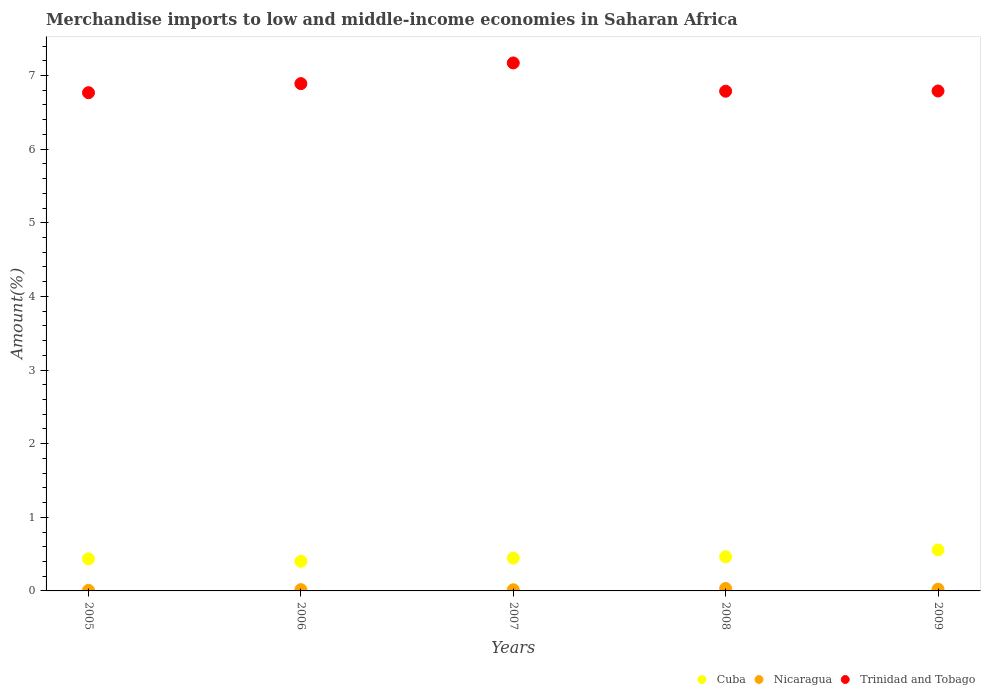How many different coloured dotlines are there?
Offer a terse response. 3. What is the percentage of amount earned from merchandise imports in Trinidad and Tobago in 2009?
Give a very brief answer. 6.79. Across all years, what is the maximum percentage of amount earned from merchandise imports in Trinidad and Tobago?
Give a very brief answer. 7.17. Across all years, what is the minimum percentage of amount earned from merchandise imports in Cuba?
Keep it short and to the point. 0.4. What is the total percentage of amount earned from merchandise imports in Nicaragua in the graph?
Your answer should be very brief. 0.1. What is the difference between the percentage of amount earned from merchandise imports in Cuba in 2006 and that in 2009?
Your answer should be compact. -0.15. What is the difference between the percentage of amount earned from merchandise imports in Cuba in 2006 and the percentage of amount earned from merchandise imports in Trinidad and Tobago in 2008?
Provide a succinct answer. -6.38. What is the average percentage of amount earned from merchandise imports in Cuba per year?
Your response must be concise. 0.46. In the year 2009, what is the difference between the percentage of amount earned from merchandise imports in Cuba and percentage of amount earned from merchandise imports in Trinidad and Tobago?
Keep it short and to the point. -6.23. In how many years, is the percentage of amount earned from merchandise imports in Cuba greater than 0.2 %?
Keep it short and to the point. 5. What is the ratio of the percentage of amount earned from merchandise imports in Nicaragua in 2006 to that in 2009?
Provide a succinct answer. 0.74. Is the percentage of amount earned from merchandise imports in Nicaragua in 2006 less than that in 2009?
Your answer should be very brief. Yes. What is the difference between the highest and the second highest percentage of amount earned from merchandise imports in Cuba?
Your response must be concise. 0.09. What is the difference between the highest and the lowest percentage of amount earned from merchandise imports in Cuba?
Make the answer very short. 0.15. In how many years, is the percentage of amount earned from merchandise imports in Trinidad and Tobago greater than the average percentage of amount earned from merchandise imports in Trinidad and Tobago taken over all years?
Your response must be concise. 2. Is the sum of the percentage of amount earned from merchandise imports in Nicaragua in 2006 and 2007 greater than the maximum percentage of amount earned from merchandise imports in Trinidad and Tobago across all years?
Keep it short and to the point. No. Does the percentage of amount earned from merchandise imports in Cuba monotonically increase over the years?
Offer a terse response. No. Is the percentage of amount earned from merchandise imports in Trinidad and Tobago strictly greater than the percentage of amount earned from merchandise imports in Cuba over the years?
Offer a terse response. Yes. How many dotlines are there?
Your response must be concise. 3. How many years are there in the graph?
Your answer should be compact. 5. What is the difference between two consecutive major ticks on the Y-axis?
Give a very brief answer. 1. Are the values on the major ticks of Y-axis written in scientific E-notation?
Provide a short and direct response. No. Does the graph contain any zero values?
Your response must be concise. No. How many legend labels are there?
Offer a terse response. 3. How are the legend labels stacked?
Your response must be concise. Horizontal. What is the title of the graph?
Your answer should be compact. Merchandise imports to low and middle-income economies in Saharan Africa. Does "Czech Republic" appear as one of the legend labels in the graph?
Your answer should be compact. No. What is the label or title of the Y-axis?
Provide a succinct answer. Amount(%). What is the Amount(%) of Cuba in 2005?
Your answer should be very brief. 0.44. What is the Amount(%) in Nicaragua in 2005?
Your response must be concise. 0.01. What is the Amount(%) of Trinidad and Tobago in 2005?
Your answer should be compact. 6.77. What is the Amount(%) in Cuba in 2006?
Keep it short and to the point. 0.4. What is the Amount(%) in Nicaragua in 2006?
Give a very brief answer. 0.02. What is the Amount(%) of Trinidad and Tobago in 2006?
Keep it short and to the point. 6.89. What is the Amount(%) in Cuba in 2007?
Make the answer very short. 0.45. What is the Amount(%) in Nicaragua in 2007?
Provide a succinct answer. 0.02. What is the Amount(%) in Trinidad and Tobago in 2007?
Provide a succinct answer. 7.17. What is the Amount(%) in Cuba in 2008?
Give a very brief answer. 0.46. What is the Amount(%) in Nicaragua in 2008?
Keep it short and to the point. 0.03. What is the Amount(%) in Trinidad and Tobago in 2008?
Your answer should be very brief. 6.79. What is the Amount(%) of Cuba in 2009?
Offer a terse response. 0.56. What is the Amount(%) of Nicaragua in 2009?
Offer a very short reply. 0.02. What is the Amount(%) in Trinidad and Tobago in 2009?
Provide a short and direct response. 6.79. Across all years, what is the maximum Amount(%) in Cuba?
Make the answer very short. 0.56. Across all years, what is the maximum Amount(%) of Nicaragua?
Your answer should be compact. 0.03. Across all years, what is the maximum Amount(%) of Trinidad and Tobago?
Keep it short and to the point. 7.17. Across all years, what is the minimum Amount(%) of Cuba?
Provide a succinct answer. 0.4. Across all years, what is the minimum Amount(%) of Nicaragua?
Offer a terse response. 0.01. Across all years, what is the minimum Amount(%) of Trinidad and Tobago?
Give a very brief answer. 6.77. What is the total Amount(%) of Cuba in the graph?
Keep it short and to the point. 2.3. What is the total Amount(%) of Nicaragua in the graph?
Give a very brief answer. 0.1. What is the total Amount(%) of Trinidad and Tobago in the graph?
Provide a succinct answer. 34.4. What is the difference between the Amount(%) in Cuba in 2005 and that in 2006?
Your response must be concise. 0.03. What is the difference between the Amount(%) of Nicaragua in 2005 and that in 2006?
Provide a succinct answer. -0.01. What is the difference between the Amount(%) of Trinidad and Tobago in 2005 and that in 2006?
Your answer should be compact. -0.12. What is the difference between the Amount(%) in Cuba in 2005 and that in 2007?
Ensure brevity in your answer.  -0.01. What is the difference between the Amount(%) of Nicaragua in 2005 and that in 2007?
Make the answer very short. -0.01. What is the difference between the Amount(%) of Trinidad and Tobago in 2005 and that in 2007?
Ensure brevity in your answer.  -0.4. What is the difference between the Amount(%) in Cuba in 2005 and that in 2008?
Offer a very short reply. -0.03. What is the difference between the Amount(%) in Nicaragua in 2005 and that in 2008?
Your response must be concise. -0.03. What is the difference between the Amount(%) in Trinidad and Tobago in 2005 and that in 2008?
Make the answer very short. -0.02. What is the difference between the Amount(%) of Cuba in 2005 and that in 2009?
Make the answer very short. -0.12. What is the difference between the Amount(%) in Nicaragua in 2005 and that in 2009?
Make the answer very short. -0.02. What is the difference between the Amount(%) in Trinidad and Tobago in 2005 and that in 2009?
Your answer should be compact. -0.02. What is the difference between the Amount(%) in Cuba in 2006 and that in 2007?
Make the answer very short. -0.04. What is the difference between the Amount(%) of Nicaragua in 2006 and that in 2007?
Provide a short and direct response. 0. What is the difference between the Amount(%) in Trinidad and Tobago in 2006 and that in 2007?
Make the answer very short. -0.28. What is the difference between the Amount(%) of Cuba in 2006 and that in 2008?
Offer a very short reply. -0.06. What is the difference between the Amount(%) in Nicaragua in 2006 and that in 2008?
Keep it short and to the point. -0.02. What is the difference between the Amount(%) of Trinidad and Tobago in 2006 and that in 2008?
Keep it short and to the point. 0.1. What is the difference between the Amount(%) of Cuba in 2006 and that in 2009?
Your answer should be compact. -0.15. What is the difference between the Amount(%) in Nicaragua in 2006 and that in 2009?
Your response must be concise. -0.01. What is the difference between the Amount(%) in Trinidad and Tobago in 2006 and that in 2009?
Your response must be concise. 0.1. What is the difference between the Amount(%) in Cuba in 2007 and that in 2008?
Provide a succinct answer. -0.02. What is the difference between the Amount(%) in Nicaragua in 2007 and that in 2008?
Your answer should be compact. -0.02. What is the difference between the Amount(%) of Trinidad and Tobago in 2007 and that in 2008?
Your response must be concise. 0.38. What is the difference between the Amount(%) of Cuba in 2007 and that in 2009?
Offer a very short reply. -0.11. What is the difference between the Amount(%) of Nicaragua in 2007 and that in 2009?
Your answer should be compact. -0.01. What is the difference between the Amount(%) of Trinidad and Tobago in 2007 and that in 2009?
Keep it short and to the point. 0.38. What is the difference between the Amount(%) of Cuba in 2008 and that in 2009?
Offer a very short reply. -0.09. What is the difference between the Amount(%) in Nicaragua in 2008 and that in 2009?
Give a very brief answer. 0.01. What is the difference between the Amount(%) of Trinidad and Tobago in 2008 and that in 2009?
Provide a short and direct response. -0. What is the difference between the Amount(%) of Cuba in 2005 and the Amount(%) of Nicaragua in 2006?
Your response must be concise. 0.42. What is the difference between the Amount(%) of Cuba in 2005 and the Amount(%) of Trinidad and Tobago in 2006?
Offer a terse response. -6.45. What is the difference between the Amount(%) in Nicaragua in 2005 and the Amount(%) in Trinidad and Tobago in 2006?
Provide a short and direct response. -6.88. What is the difference between the Amount(%) in Cuba in 2005 and the Amount(%) in Nicaragua in 2007?
Offer a terse response. 0.42. What is the difference between the Amount(%) in Cuba in 2005 and the Amount(%) in Trinidad and Tobago in 2007?
Ensure brevity in your answer.  -6.74. What is the difference between the Amount(%) in Nicaragua in 2005 and the Amount(%) in Trinidad and Tobago in 2007?
Give a very brief answer. -7.16. What is the difference between the Amount(%) in Cuba in 2005 and the Amount(%) in Nicaragua in 2008?
Ensure brevity in your answer.  0.4. What is the difference between the Amount(%) of Cuba in 2005 and the Amount(%) of Trinidad and Tobago in 2008?
Your answer should be compact. -6.35. What is the difference between the Amount(%) of Nicaragua in 2005 and the Amount(%) of Trinidad and Tobago in 2008?
Give a very brief answer. -6.78. What is the difference between the Amount(%) of Cuba in 2005 and the Amount(%) of Nicaragua in 2009?
Your answer should be very brief. 0.41. What is the difference between the Amount(%) of Cuba in 2005 and the Amount(%) of Trinidad and Tobago in 2009?
Your answer should be compact. -6.35. What is the difference between the Amount(%) in Nicaragua in 2005 and the Amount(%) in Trinidad and Tobago in 2009?
Ensure brevity in your answer.  -6.78. What is the difference between the Amount(%) in Cuba in 2006 and the Amount(%) in Nicaragua in 2007?
Provide a short and direct response. 0.39. What is the difference between the Amount(%) of Cuba in 2006 and the Amount(%) of Trinidad and Tobago in 2007?
Give a very brief answer. -6.77. What is the difference between the Amount(%) of Nicaragua in 2006 and the Amount(%) of Trinidad and Tobago in 2007?
Ensure brevity in your answer.  -7.15. What is the difference between the Amount(%) in Cuba in 2006 and the Amount(%) in Nicaragua in 2008?
Make the answer very short. 0.37. What is the difference between the Amount(%) of Cuba in 2006 and the Amount(%) of Trinidad and Tobago in 2008?
Offer a terse response. -6.38. What is the difference between the Amount(%) of Nicaragua in 2006 and the Amount(%) of Trinidad and Tobago in 2008?
Provide a succinct answer. -6.77. What is the difference between the Amount(%) of Cuba in 2006 and the Amount(%) of Nicaragua in 2009?
Make the answer very short. 0.38. What is the difference between the Amount(%) of Cuba in 2006 and the Amount(%) of Trinidad and Tobago in 2009?
Give a very brief answer. -6.39. What is the difference between the Amount(%) in Nicaragua in 2006 and the Amount(%) in Trinidad and Tobago in 2009?
Offer a very short reply. -6.77. What is the difference between the Amount(%) in Cuba in 2007 and the Amount(%) in Nicaragua in 2008?
Your answer should be very brief. 0.41. What is the difference between the Amount(%) in Cuba in 2007 and the Amount(%) in Trinidad and Tobago in 2008?
Your answer should be compact. -6.34. What is the difference between the Amount(%) of Nicaragua in 2007 and the Amount(%) of Trinidad and Tobago in 2008?
Offer a terse response. -6.77. What is the difference between the Amount(%) in Cuba in 2007 and the Amount(%) in Nicaragua in 2009?
Offer a very short reply. 0.42. What is the difference between the Amount(%) in Cuba in 2007 and the Amount(%) in Trinidad and Tobago in 2009?
Offer a terse response. -6.34. What is the difference between the Amount(%) in Nicaragua in 2007 and the Amount(%) in Trinidad and Tobago in 2009?
Your answer should be compact. -6.77. What is the difference between the Amount(%) in Cuba in 2008 and the Amount(%) in Nicaragua in 2009?
Your answer should be very brief. 0.44. What is the difference between the Amount(%) of Cuba in 2008 and the Amount(%) of Trinidad and Tobago in 2009?
Your answer should be compact. -6.33. What is the difference between the Amount(%) of Nicaragua in 2008 and the Amount(%) of Trinidad and Tobago in 2009?
Offer a very short reply. -6.76. What is the average Amount(%) in Cuba per year?
Your response must be concise. 0.46. What is the average Amount(%) in Nicaragua per year?
Ensure brevity in your answer.  0.02. What is the average Amount(%) of Trinidad and Tobago per year?
Your answer should be compact. 6.88. In the year 2005, what is the difference between the Amount(%) in Cuba and Amount(%) in Nicaragua?
Your response must be concise. 0.43. In the year 2005, what is the difference between the Amount(%) in Cuba and Amount(%) in Trinidad and Tobago?
Ensure brevity in your answer.  -6.33. In the year 2005, what is the difference between the Amount(%) of Nicaragua and Amount(%) of Trinidad and Tobago?
Ensure brevity in your answer.  -6.76. In the year 2006, what is the difference between the Amount(%) of Cuba and Amount(%) of Nicaragua?
Give a very brief answer. 0.39. In the year 2006, what is the difference between the Amount(%) in Cuba and Amount(%) in Trinidad and Tobago?
Provide a succinct answer. -6.49. In the year 2006, what is the difference between the Amount(%) of Nicaragua and Amount(%) of Trinidad and Tobago?
Ensure brevity in your answer.  -6.87. In the year 2007, what is the difference between the Amount(%) of Cuba and Amount(%) of Nicaragua?
Your response must be concise. 0.43. In the year 2007, what is the difference between the Amount(%) in Cuba and Amount(%) in Trinidad and Tobago?
Make the answer very short. -6.72. In the year 2007, what is the difference between the Amount(%) of Nicaragua and Amount(%) of Trinidad and Tobago?
Ensure brevity in your answer.  -7.16. In the year 2008, what is the difference between the Amount(%) in Cuba and Amount(%) in Nicaragua?
Make the answer very short. 0.43. In the year 2008, what is the difference between the Amount(%) of Cuba and Amount(%) of Trinidad and Tobago?
Provide a short and direct response. -6.32. In the year 2008, what is the difference between the Amount(%) of Nicaragua and Amount(%) of Trinidad and Tobago?
Keep it short and to the point. -6.75. In the year 2009, what is the difference between the Amount(%) in Cuba and Amount(%) in Nicaragua?
Your answer should be very brief. 0.53. In the year 2009, what is the difference between the Amount(%) in Cuba and Amount(%) in Trinidad and Tobago?
Offer a very short reply. -6.23. In the year 2009, what is the difference between the Amount(%) of Nicaragua and Amount(%) of Trinidad and Tobago?
Provide a succinct answer. -6.77. What is the ratio of the Amount(%) in Cuba in 2005 to that in 2006?
Ensure brevity in your answer.  1.08. What is the ratio of the Amount(%) of Nicaragua in 2005 to that in 2006?
Give a very brief answer. 0.43. What is the ratio of the Amount(%) of Trinidad and Tobago in 2005 to that in 2006?
Provide a short and direct response. 0.98. What is the ratio of the Amount(%) of Cuba in 2005 to that in 2007?
Ensure brevity in your answer.  0.98. What is the ratio of the Amount(%) of Nicaragua in 2005 to that in 2007?
Keep it short and to the point. 0.48. What is the ratio of the Amount(%) of Trinidad and Tobago in 2005 to that in 2007?
Provide a short and direct response. 0.94. What is the ratio of the Amount(%) of Cuba in 2005 to that in 2008?
Your answer should be very brief. 0.94. What is the ratio of the Amount(%) of Nicaragua in 2005 to that in 2008?
Offer a very short reply. 0.23. What is the ratio of the Amount(%) of Trinidad and Tobago in 2005 to that in 2008?
Provide a succinct answer. 1. What is the ratio of the Amount(%) of Cuba in 2005 to that in 2009?
Your answer should be very brief. 0.78. What is the ratio of the Amount(%) of Nicaragua in 2005 to that in 2009?
Make the answer very short. 0.32. What is the ratio of the Amount(%) in Trinidad and Tobago in 2005 to that in 2009?
Provide a succinct answer. 1. What is the ratio of the Amount(%) in Cuba in 2006 to that in 2007?
Your answer should be very brief. 0.9. What is the ratio of the Amount(%) in Nicaragua in 2006 to that in 2007?
Your answer should be compact. 1.11. What is the ratio of the Amount(%) in Trinidad and Tobago in 2006 to that in 2007?
Make the answer very short. 0.96. What is the ratio of the Amount(%) of Cuba in 2006 to that in 2008?
Provide a short and direct response. 0.87. What is the ratio of the Amount(%) of Nicaragua in 2006 to that in 2008?
Make the answer very short. 0.53. What is the ratio of the Amount(%) in Trinidad and Tobago in 2006 to that in 2008?
Your answer should be very brief. 1.02. What is the ratio of the Amount(%) of Cuba in 2006 to that in 2009?
Your answer should be very brief. 0.72. What is the ratio of the Amount(%) in Nicaragua in 2006 to that in 2009?
Make the answer very short. 0.74. What is the ratio of the Amount(%) in Trinidad and Tobago in 2006 to that in 2009?
Your answer should be very brief. 1.01. What is the ratio of the Amount(%) in Cuba in 2007 to that in 2008?
Your answer should be very brief. 0.96. What is the ratio of the Amount(%) of Nicaragua in 2007 to that in 2008?
Your response must be concise. 0.47. What is the ratio of the Amount(%) in Trinidad and Tobago in 2007 to that in 2008?
Give a very brief answer. 1.06. What is the ratio of the Amount(%) of Cuba in 2007 to that in 2009?
Keep it short and to the point. 0.8. What is the ratio of the Amount(%) in Nicaragua in 2007 to that in 2009?
Offer a terse response. 0.67. What is the ratio of the Amount(%) of Trinidad and Tobago in 2007 to that in 2009?
Ensure brevity in your answer.  1.06. What is the ratio of the Amount(%) in Cuba in 2008 to that in 2009?
Provide a short and direct response. 0.83. What is the ratio of the Amount(%) in Nicaragua in 2008 to that in 2009?
Make the answer very short. 1.41. What is the difference between the highest and the second highest Amount(%) in Cuba?
Provide a short and direct response. 0.09. What is the difference between the highest and the second highest Amount(%) of Nicaragua?
Keep it short and to the point. 0.01. What is the difference between the highest and the second highest Amount(%) of Trinidad and Tobago?
Offer a terse response. 0.28. What is the difference between the highest and the lowest Amount(%) in Cuba?
Provide a succinct answer. 0.15. What is the difference between the highest and the lowest Amount(%) of Nicaragua?
Offer a very short reply. 0.03. What is the difference between the highest and the lowest Amount(%) in Trinidad and Tobago?
Keep it short and to the point. 0.4. 